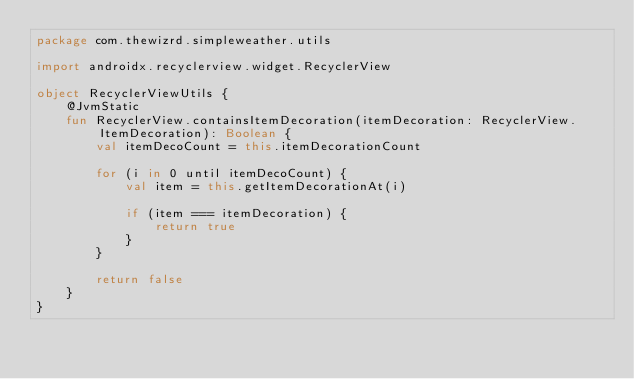Convert code to text. <code><loc_0><loc_0><loc_500><loc_500><_Kotlin_>package com.thewizrd.simpleweather.utils

import androidx.recyclerview.widget.RecyclerView

object RecyclerViewUtils {
    @JvmStatic
    fun RecyclerView.containsItemDecoration(itemDecoration: RecyclerView.ItemDecoration): Boolean {
        val itemDecoCount = this.itemDecorationCount

        for (i in 0 until itemDecoCount) {
            val item = this.getItemDecorationAt(i)

            if (item === itemDecoration) {
                return true
            }
        }

        return false
    }
}</code> 